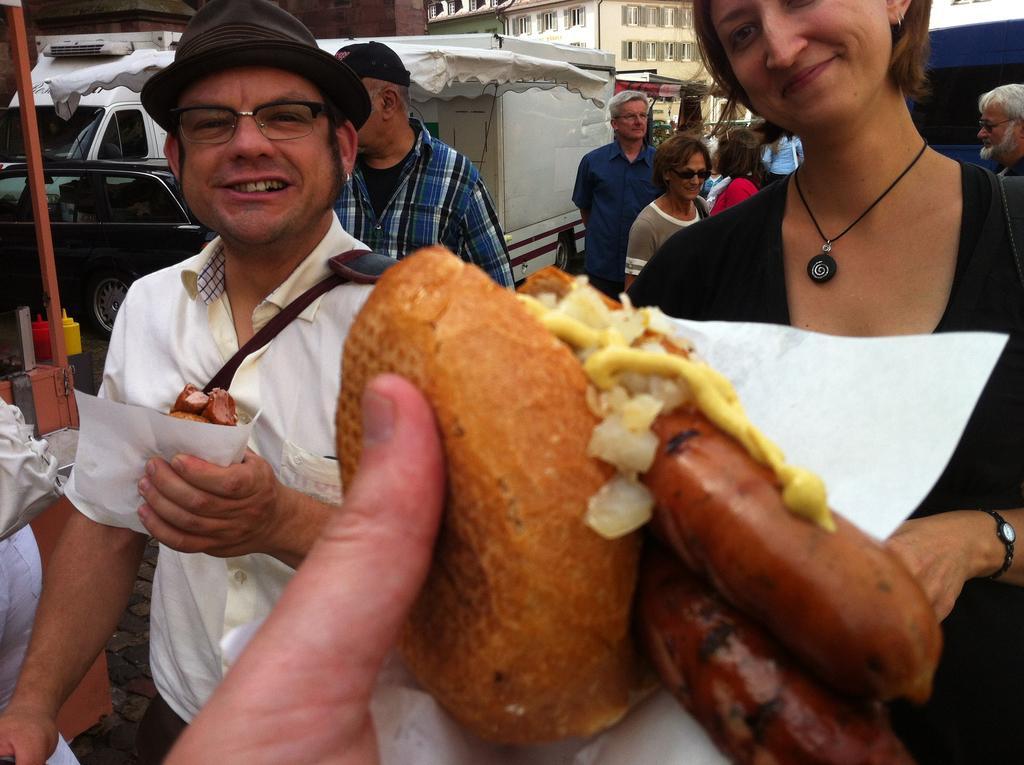In one or two sentences, can you explain what this image depicts? In this image there is a hand holding food item, in the background there are people standing and there are stalls and buildings and cars. 